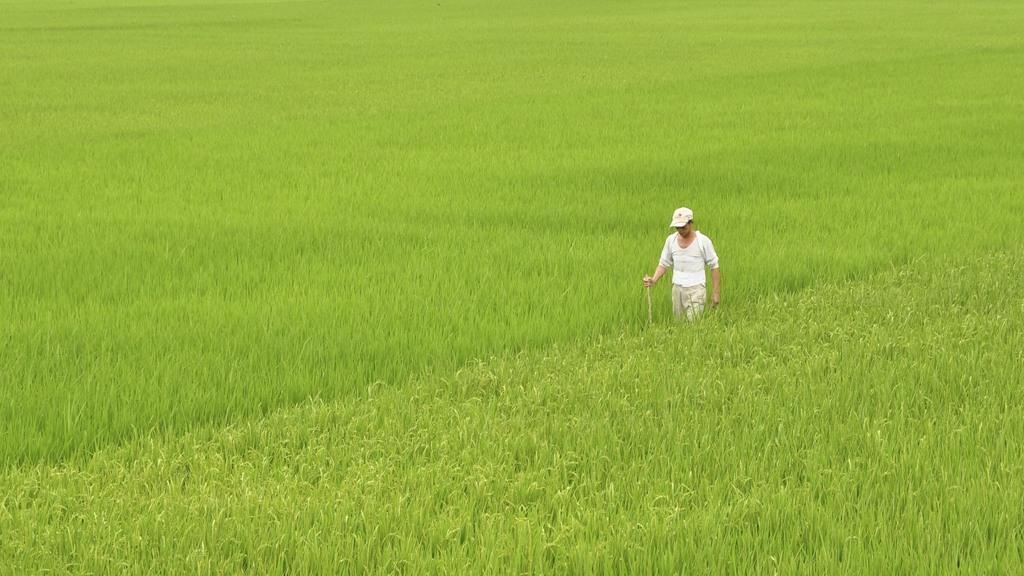Please provide a concise description of this image. In the middle a man is there, he wore white color t-shirt and a cap. This is the crop. 